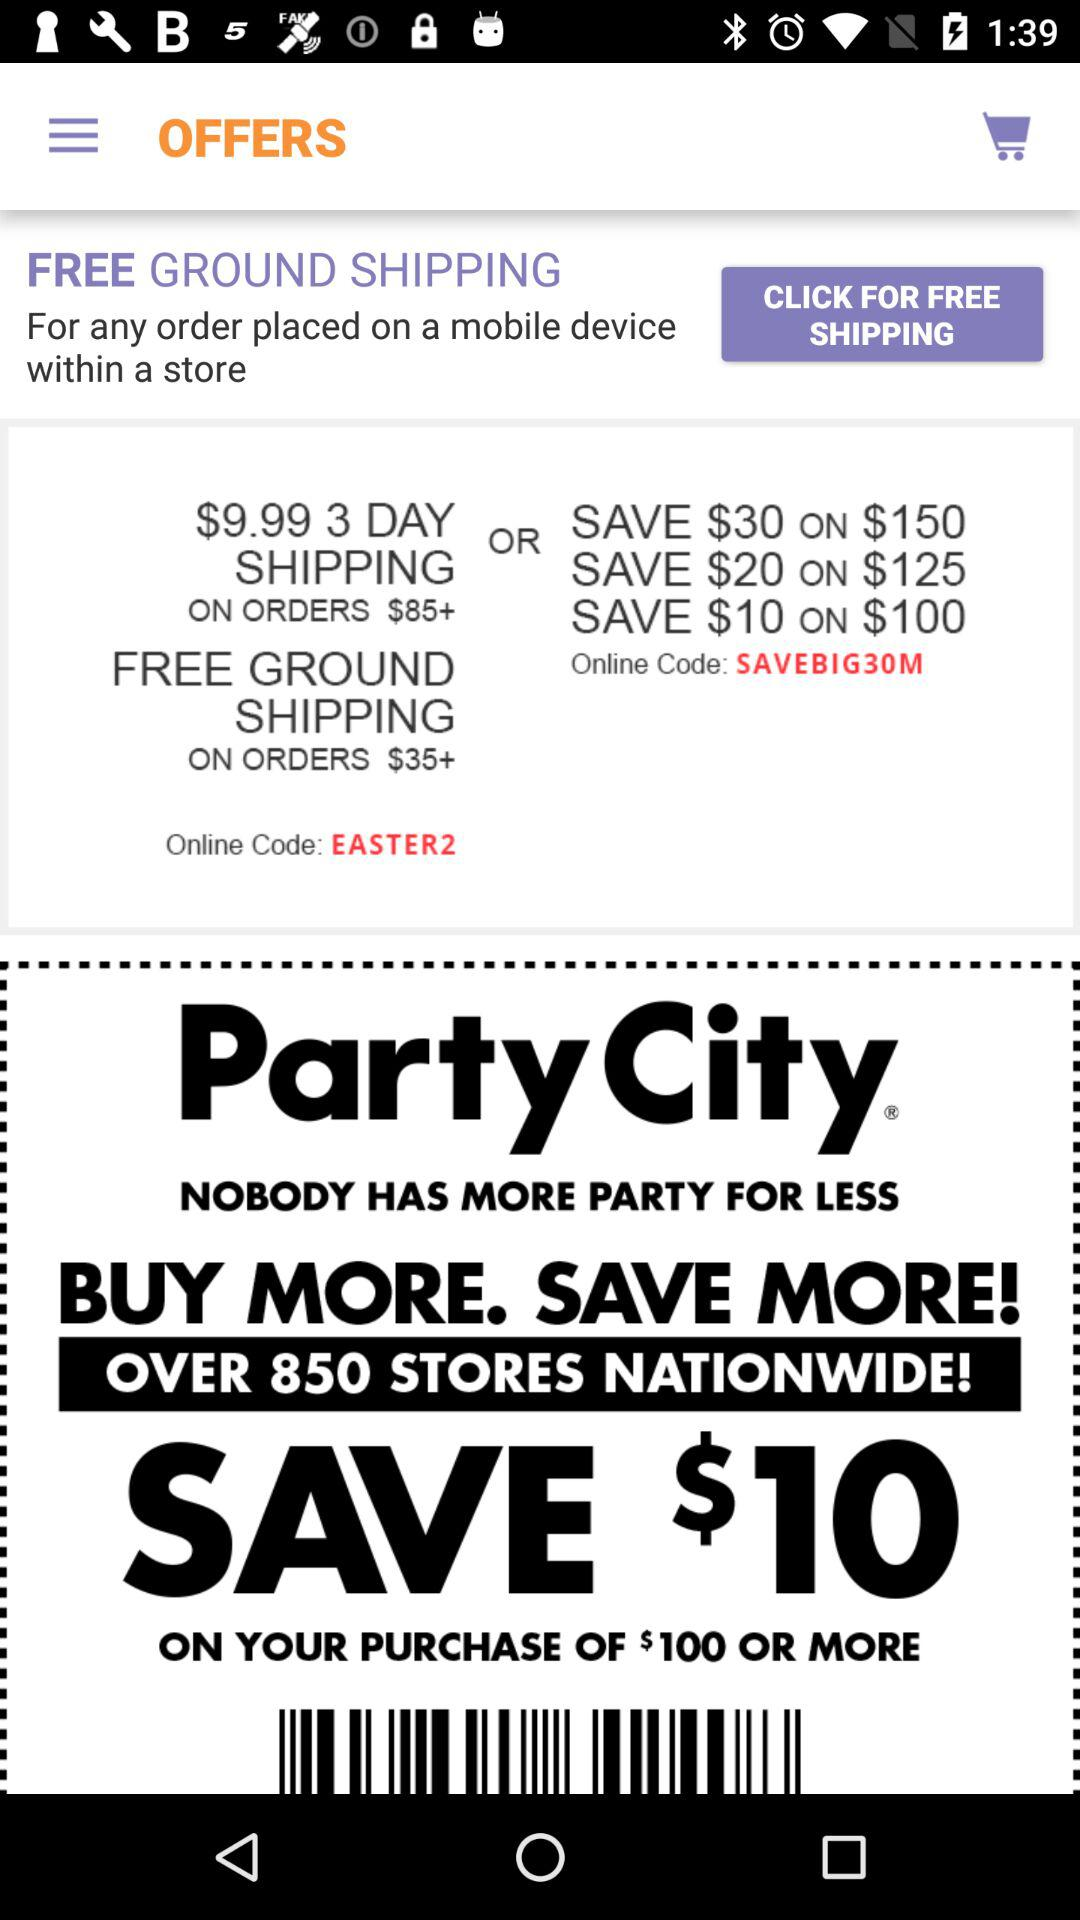What is the online code for free ground shipping on orders? The online code for free ground shipping on orders is "EASTER2". 